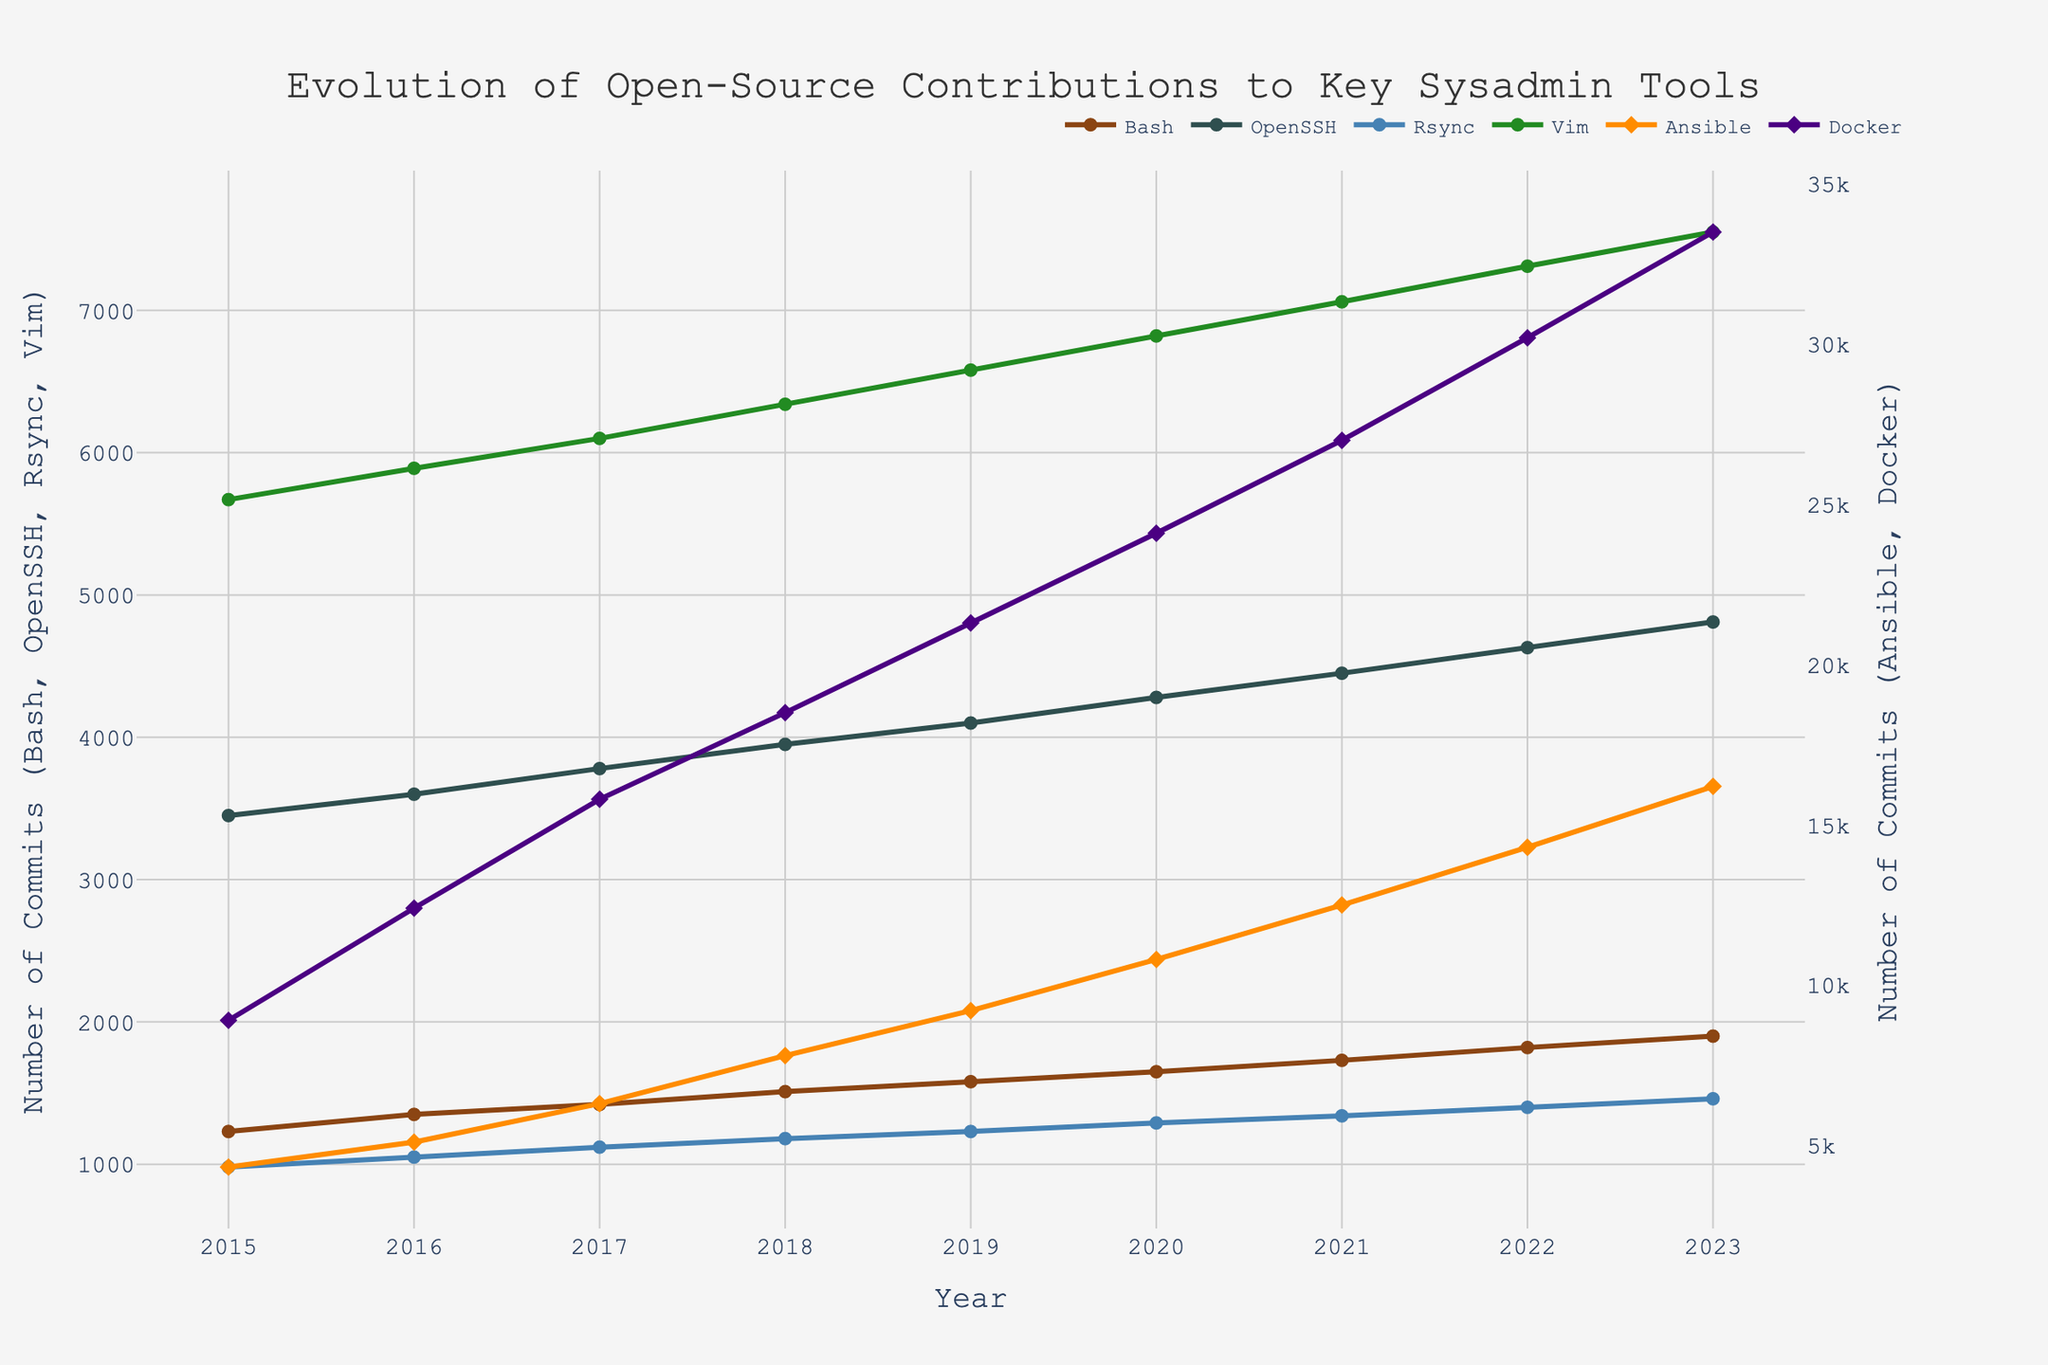What's the overall trend for open-source contributions to Docker from 2015 to 2023? To determine the trend, observe the data points for Docker from 2015 to 2023. The number of commits increases each year, indicating an upward trend.
Answer: Upward How many total commits were made to Bash in the years 2016 and 2018 combined? Add the number of commits for Bash in 2016 (1350) and 2018 (1510): 1350 + 1510 = 2860
Answer: 2860 Which tool had the highest number of commits in 2023, and what was that number? Look at the data points for 2023. Docker has the highest number of commits at 33500.
Answer: Docker: 33500 How does the number of commits for OpenSSH in 2020 compare to Vim in 2020? Compare the data points for OpenSSH and Vim in 2020. OpenSSH has 4280 commits, while Vim has 6820 commits. OpenSSH has fewer commits than Vim.
Answer: OpenSSH < Vim What is the average number of commits for Rsync over the period 2015 to 2023? Sum the number of commits for Rsync from 2015 to 2023 and then divide by the number of years (9). Sum: 980 + 1050 + 1120 + 1180 + 1230 + 1290 + 1340 + 1400 + 1460 = 11050. Average: 11050/9 ≈ 1228
Answer: 1228 Which year shows the steepest increase in the number of commits for Ansible? Calculate the year-over-year difference for Ansible and find the maximum. The largest jump is from 2017 (6300) to 2018 (7800), with an increase of 1500 commits.
Answer: 2018 Compare the number of commits for Docker and Ansible in 2018. Which one is higher and by how much? Compare the data points in 2018. Docker has 18500 commits, while Ansible has 7800 commits. The difference is 18500 - 7800 = 10700.
Answer: Docker by 10700 What is the visual representation (color and marker) used for Vim in this plot? According to the plot specifications, Vim uses a green line with circle markers.
Answer: Green line with circle markers If you sum the contributions to Bash, OpenSSH, and Rsync in the year 2019, what is the total number of commits? Add the number of commits for Bash (1580), OpenSSH (4100), and Rsync (1230) in 2019: 1580 + 4100 + 1230 = 6910
Answer: 6910 